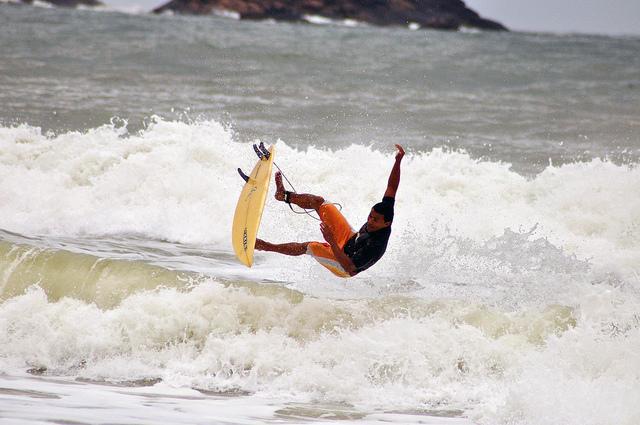Is this a pond?
Concise answer only. No. What is the man doing in the water?
Concise answer only. Surfing. What color is the surfer's trunks?
Short answer required. Orange. 